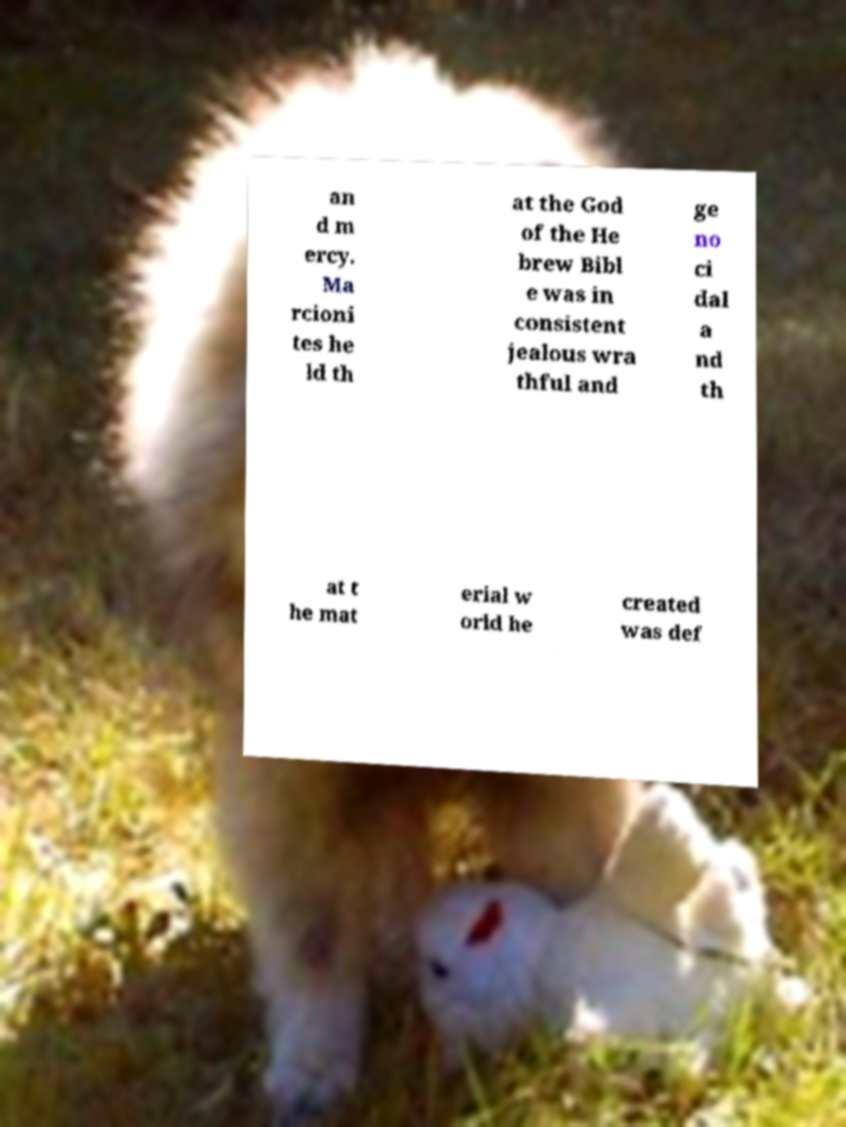Can you accurately transcribe the text from the provided image for me? an d m ercy. Ma rcioni tes he ld th at the God of the He brew Bibl e was in consistent jealous wra thful and ge no ci dal a nd th at t he mat erial w orld he created was def 